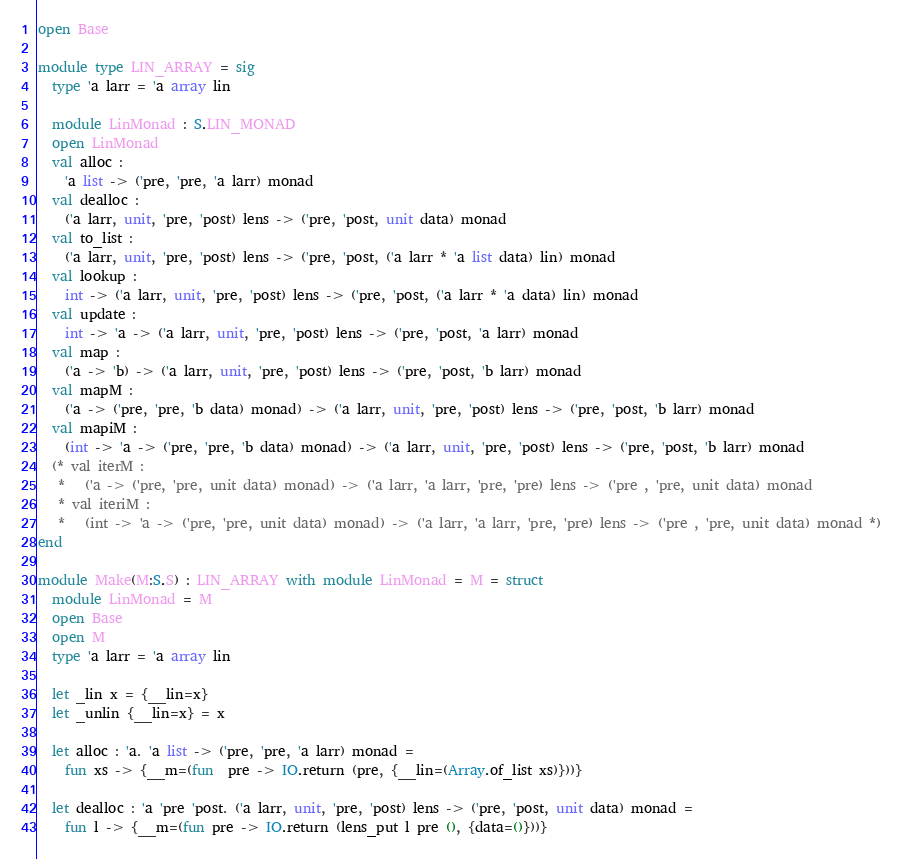<code> <loc_0><loc_0><loc_500><loc_500><_OCaml_>open Base

module type LIN_ARRAY = sig
  type 'a larr = 'a array lin

  module LinMonad : S.LIN_MONAD
  open LinMonad
  val alloc :
    'a list -> ('pre, 'pre, 'a larr) monad
  val dealloc :
    ('a larr, unit, 'pre, 'post) lens -> ('pre, 'post, unit data) monad
  val to_list :
    ('a larr, unit, 'pre, 'post) lens -> ('pre, 'post, ('a larr * 'a list data) lin) monad
  val lookup :
    int -> ('a larr, unit, 'pre, 'post) lens -> ('pre, 'post, ('a larr * 'a data) lin) monad
  val update :
    int -> 'a -> ('a larr, unit, 'pre, 'post) lens -> ('pre, 'post, 'a larr) monad
  val map :
    ('a -> 'b) -> ('a larr, unit, 'pre, 'post) lens -> ('pre, 'post, 'b larr) monad
  val mapM :
    ('a -> ('pre, 'pre, 'b data) monad) -> ('a larr, unit, 'pre, 'post) lens -> ('pre, 'post, 'b larr) monad
  val mapiM :
    (int -> 'a -> ('pre, 'pre, 'b data) monad) -> ('a larr, unit, 'pre, 'post) lens -> ('pre, 'post, 'b larr) monad
  (* val iterM :
   *   ('a -> ('pre, 'pre, unit data) monad) -> ('a larr, 'a larr, 'pre, 'pre) lens -> ('pre , 'pre, unit data) monad
   * val iteriM :
   *   (int -> 'a -> ('pre, 'pre, unit data) monad) -> ('a larr, 'a larr, 'pre, 'pre) lens -> ('pre , 'pre, unit data) monad *)
end

module Make(M:S.S) : LIN_ARRAY with module LinMonad = M = struct
  module LinMonad = M
  open Base
  open M
  type 'a larr = 'a array lin

  let _lin x = {__lin=x}
  let _unlin {__lin=x} = x

  let alloc : 'a. 'a list -> ('pre, 'pre, 'a larr) monad =
    fun xs -> {__m=(fun  pre -> IO.return (pre, {__lin=(Array.of_list xs)}))}

  let dealloc : 'a 'pre 'post. ('a larr, unit, 'pre, 'post) lens -> ('pre, 'post, unit data) monad =
    fun l -> {__m=(fun pre -> IO.return (lens_put l pre (), {data=()}))}
</code> 